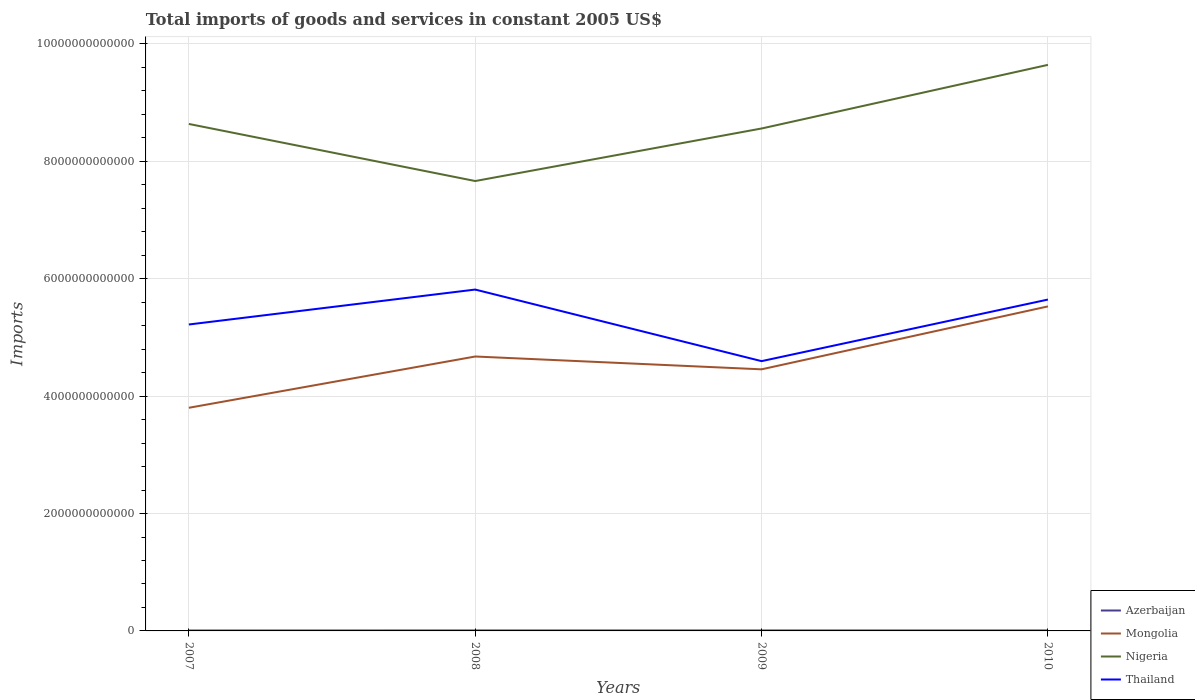How many different coloured lines are there?
Offer a very short reply. 4. Does the line corresponding to Thailand intersect with the line corresponding to Mongolia?
Your response must be concise. No. Is the number of lines equal to the number of legend labels?
Your response must be concise. Yes. Across all years, what is the maximum total imports of goods and services in Thailand?
Offer a terse response. 4.60e+12. In which year was the total imports of goods and services in Nigeria maximum?
Provide a succinct answer. 2008. What is the total total imports of goods and services in Nigeria in the graph?
Give a very brief answer. -1.08e+12. What is the difference between the highest and the second highest total imports of goods and services in Thailand?
Provide a succinct answer. 1.22e+12. What is the difference between the highest and the lowest total imports of goods and services in Thailand?
Your answer should be compact. 2. How many lines are there?
Offer a terse response. 4. How many years are there in the graph?
Give a very brief answer. 4. What is the difference between two consecutive major ticks on the Y-axis?
Provide a succinct answer. 2.00e+12. Are the values on the major ticks of Y-axis written in scientific E-notation?
Make the answer very short. No. Does the graph contain any zero values?
Keep it short and to the point. No. Does the graph contain grids?
Your answer should be very brief. Yes. Where does the legend appear in the graph?
Offer a very short reply. Bottom right. What is the title of the graph?
Your response must be concise. Total imports of goods and services in constant 2005 US$. What is the label or title of the X-axis?
Offer a terse response. Years. What is the label or title of the Y-axis?
Give a very brief answer. Imports. What is the Imports of Azerbaijan in 2007?
Offer a very short reply. 7.29e+09. What is the Imports in Mongolia in 2007?
Provide a short and direct response. 3.80e+12. What is the Imports of Nigeria in 2007?
Offer a very short reply. 8.64e+12. What is the Imports in Thailand in 2007?
Your answer should be very brief. 5.22e+12. What is the Imports of Azerbaijan in 2008?
Make the answer very short. 8.33e+09. What is the Imports in Mongolia in 2008?
Provide a short and direct response. 4.68e+12. What is the Imports of Nigeria in 2008?
Your answer should be very brief. 7.67e+12. What is the Imports of Thailand in 2008?
Ensure brevity in your answer.  5.82e+12. What is the Imports in Azerbaijan in 2009?
Your answer should be compact. 7.89e+09. What is the Imports of Mongolia in 2009?
Make the answer very short. 4.46e+12. What is the Imports in Nigeria in 2009?
Make the answer very short. 8.56e+12. What is the Imports of Thailand in 2009?
Provide a short and direct response. 4.60e+12. What is the Imports in Azerbaijan in 2010?
Keep it short and to the point. 8.00e+09. What is the Imports in Mongolia in 2010?
Your answer should be very brief. 5.53e+12. What is the Imports in Nigeria in 2010?
Ensure brevity in your answer.  9.64e+12. What is the Imports in Thailand in 2010?
Make the answer very short. 5.65e+12. Across all years, what is the maximum Imports in Azerbaijan?
Provide a short and direct response. 8.33e+09. Across all years, what is the maximum Imports in Mongolia?
Offer a very short reply. 5.53e+12. Across all years, what is the maximum Imports of Nigeria?
Your response must be concise. 9.64e+12. Across all years, what is the maximum Imports in Thailand?
Your response must be concise. 5.82e+12. Across all years, what is the minimum Imports in Azerbaijan?
Provide a succinct answer. 7.29e+09. Across all years, what is the minimum Imports in Mongolia?
Offer a terse response. 3.80e+12. Across all years, what is the minimum Imports of Nigeria?
Give a very brief answer. 7.67e+12. Across all years, what is the minimum Imports in Thailand?
Ensure brevity in your answer.  4.60e+12. What is the total Imports in Azerbaijan in the graph?
Offer a terse response. 3.15e+1. What is the total Imports of Mongolia in the graph?
Give a very brief answer. 1.85e+13. What is the total Imports of Nigeria in the graph?
Offer a very short reply. 3.45e+13. What is the total Imports of Thailand in the graph?
Offer a terse response. 2.13e+13. What is the difference between the Imports of Azerbaijan in 2007 and that in 2008?
Offer a terse response. -1.04e+09. What is the difference between the Imports of Mongolia in 2007 and that in 2008?
Offer a very short reply. -8.74e+11. What is the difference between the Imports in Nigeria in 2007 and that in 2008?
Provide a short and direct response. 9.72e+11. What is the difference between the Imports in Thailand in 2007 and that in 2008?
Ensure brevity in your answer.  -5.95e+11. What is the difference between the Imports in Azerbaijan in 2007 and that in 2009?
Offer a terse response. -6.05e+08. What is the difference between the Imports of Mongolia in 2007 and that in 2009?
Give a very brief answer. -6.55e+11. What is the difference between the Imports in Nigeria in 2007 and that in 2009?
Keep it short and to the point. 7.73e+1. What is the difference between the Imports in Thailand in 2007 and that in 2009?
Offer a very short reply. 6.24e+11. What is the difference between the Imports of Azerbaijan in 2007 and that in 2010?
Keep it short and to the point. -7.11e+08. What is the difference between the Imports in Mongolia in 2007 and that in 2010?
Your answer should be very brief. -1.73e+12. What is the difference between the Imports in Nigeria in 2007 and that in 2010?
Your answer should be very brief. -1.01e+12. What is the difference between the Imports in Thailand in 2007 and that in 2010?
Keep it short and to the point. -4.25e+11. What is the difference between the Imports in Azerbaijan in 2008 and that in 2009?
Ensure brevity in your answer.  4.40e+08. What is the difference between the Imports in Mongolia in 2008 and that in 2009?
Offer a terse response. 2.19e+11. What is the difference between the Imports in Nigeria in 2008 and that in 2009?
Make the answer very short. -8.95e+11. What is the difference between the Imports of Thailand in 2008 and that in 2009?
Offer a very short reply. 1.22e+12. What is the difference between the Imports in Azerbaijan in 2008 and that in 2010?
Your answer should be very brief. 3.33e+08. What is the difference between the Imports of Mongolia in 2008 and that in 2010?
Offer a very short reply. -8.53e+11. What is the difference between the Imports in Nigeria in 2008 and that in 2010?
Make the answer very short. -1.98e+12. What is the difference between the Imports in Thailand in 2008 and that in 2010?
Offer a terse response. 1.70e+11. What is the difference between the Imports in Azerbaijan in 2009 and that in 2010?
Offer a very short reply. -1.06e+08. What is the difference between the Imports of Mongolia in 2009 and that in 2010?
Keep it short and to the point. -1.07e+12. What is the difference between the Imports of Nigeria in 2009 and that in 2010?
Your answer should be very brief. -1.08e+12. What is the difference between the Imports in Thailand in 2009 and that in 2010?
Provide a succinct answer. -1.05e+12. What is the difference between the Imports in Azerbaijan in 2007 and the Imports in Mongolia in 2008?
Ensure brevity in your answer.  -4.67e+12. What is the difference between the Imports of Azerbaijan in 2007 and the Imports of Nigeria in 2008?
Your answer should be compact. -7.66e+12. What is the difference between the Imports in Azerbaijan in 2007 and the Imports in Thailand in 2008?
Give a very brief answer. -5.81e+12. What is the difference between the Imports in Mongolia in 2007 and the Imports in Nigeria in 2008?
Provide a succinct answer. -3.86e+12. What is the difference between the Imports in Mongolia in 2007 and the Imports in Thailand in 2008?
Provide a short and direct response. -2.01e+12. What is the difference between the Imports of Nigeria in 2007 and the Imports of Thailand in 2008?
Provide a short and direct response. 2.82e+12. What is the difference between the Imports of Azerbaijan in 2007 and the Imports of Mongolia in 2009?
Offer a very short reply. -4.45e+12. What is the difference between the Imports of Azerbaijan in 2007 and the Imports of Nigeria in 2009?
Offer a terse response. -8.55e+12. What is the difference between the Imports in Azerbaijan in 2007 and the Imports in Thailand in 2009?
Ensure brevity in your answer.  -4.59e+12. What is the difference between the Imports of Mongolia in 2007 and the Imports of Nigeria in 2009?
Offer a very short reply. -4.76e+12. What is the difference between the Imports in Mongolia in 2007 and the Imports in Thailand in 2009?
Keep it short and to the point. -7.95e+11. What is the difference between the Imports of Nigeria in 2007 and the Imports of Thailand in 2009?
Provide a succinct answer. 4.04e+12. What is the difference between the Imports of Azerbaijan in 2007 and the Imports of Mongolia in 2010?
Provide a succinct answer. -5.52e+12. What is the difference between the Imports of Azerbaijan in 2007 and the Imports of Nigeria in 2010?
Give a very brief answer. -9.64e+12. What is the difference between the Imports of Azerbaijan in 2007 and the Imports of Thailand in 2010?
Offer a terse response. -5.64e+12. What is the difference between the Imports of Mongolia in 2007 and the Imports of Nigeria in 2010?
Keep it short and to the point. -5.84e+12. What is the difference between the Imports of Mongolia in 2007 and the Imports of Thailand in 2010?
Your answer should be very brief. -1.84e+12. What is the difference between the Imports in Nigeria in 2007 and the Imports in Thailand in 2010?
Provide a succinct answer. 2.99e+12. What is the difference between the Imports in Azerbaijan in 2008 and the Imports in Mongolia in 2009?
Your answer should be compact. -4.45e+12. What is the difference between the Imports in Azerbaijan in 2008 and the Imports in Nigeria in 2009?
Your answer should be very brief. -8.55e+12. What is the difference between the Imports of Azerbaijan in 2008 and the Imports of Thailand in 2009?
Make the answer very short. -4.59e+12. What is the difference between the Imports of Mongolia in 2008 and the Imports of Nigeria in 2009?
Offer a terse response. -3.88e+12. What is the difference between the Imports of Mongolia in 2008 and the Imports of Thailand in 2009?
Provide a short and direct response. 7.91e+1. What is the difference between the Imports of Nigeria in 2008 and the Imports of Thailand in 2009?
Your answer should be very brief. 3.07e+12. What is the difference between the Imports in Azerbaijan in 2008 and the Imports in Mongolia in 2010?
Offer a very short reply. -5.52e+12. What is the difference between the Imports of Azerbaijan in 2008 and the Imports of Nigeria in 2010?
Your response must be concise. -9.64e+12. What is the difference between the Imports of Azerbaijan in 2008 and the Imports of Thailand in 2010?
Offer a very short reply. -5.64e+12. What is the difference between the Imports in Mongolia in 2008 and the Imports in Nigeria in 2010?
Give a very brief answer. -4.97e+12. What is the difference between the Imports in Mongolia in 2008 and the Imports in Thailand in 2010?
Ensure brevity in your answer.  -9.70e+11. What is the difference between the Imports in Nigeria in 2008 and the Imports in Thailand in 2010?
Keep it short and to the point. 2.02e+12. What is the difference between the Imports in Azerbaijan in 2009 and the Imports in Mongolia in 2010?
Provide a succinct answer. -5.52e+12. What is the difference between the Imports of Azerbaijan in 2009 and the Imports of Nigeria in 2010?
Ensure brevity in your answer.  -9.64e+12. What is the difference between the Imports of Azerbaijan in 2009 and the Imports of Thailand in 2010?
Your response must be concise. -5.64e+12. What is the difference between the Imports of Mongolia in 2009 and the Imports of Nigeria in 2010?
Provide a succinct answer. -5.19e+12. What is the difference between the Imports in Mongolia in 2009 and the Imports in Thailand in 2010?
Offer a very short reply. -1.19e+12. What is the difference between the Imports of Nigeria in 2009 and the Imports of Thailand in 2010?
Give a very brief answer. 2.91e+12. What is the average Imports of Azerbaijan per year?
Make the answer very short. 7.88e+09. What is the average Imports of Mongolia per year?
Your answer should be compact. 4.62e+12. What is the average Imports of Nigeria per year?
Keep it short and to the point. 8.63e+12. What is the average Imports of Thailand per year?
Give a very brief answer. 5.32e+12. In the year 2007, what is the difference between the Imports in Azerbaijan and Imports in Mongolia?
Ensure brevity in your answer.  -3.79e+12. In the year 2007, what is the difference between the Imports in Azerbaijan and Imports in Nigeria?
Your response must be concise. -8.63e+12. In the year 2007, what is the difference between the Imports of Azerbaijan and Imports of Thailand?
Your response must be concise. -5.21e+12. In the year 2007, what is the difference between the Imports of Mongolia and Imports of Nigeria?
Your answer should be compact. -4.84e+12. In the year 2007, what is the difference between the Imports in Mongolia and Imports in Thailand?
Provide a succinct answer. -1.42e+12. In the year 2007, what is the difference between the Imports of Nigeria and Imports of Thailand?
Offer a very short reply. 3.42e+12. In the year 2008, what is the difference between the Imports of Azerbaijan and Imports of Mongolia?
Provide a short and direct response. -4.67e+12. In the year 2008, what is the difference between the Imports of Azerbaijan and Imports of Nigeria?
Ensure brevity in your answer.  -7.66e+12. In the year 2008, what is the difference between the Imports in Azerbaijan and Imports in Thailand?
Your answer should be very brief. -5.81e+12. In the year 2008, what is the difference between the Imports of Mongolia and Imports of Nigeria?
Make the answer very short. -2.99e+12. In the year 2008, what is the difference between the Imports in Mongolia and Imports in Thailand?
Make the answer very short. -1.14e+12. In the year 2008, what is the difference between the Imports in Nigeria and Imports in Thailand?
Provide a succinct answer. 1.85e+12. In the year 2009, what is the difference between the Imports of Azerbaijan and Imports of Mongolia?
Make the answer very short. -4.45e+12. In the year 2009, what is the difference between the Imports in Azerbaijan and Imports in Nigeria?
Provide a short and direct response. -8.55e+12. In the year 2009, what is the difference between the Imports of Azerbaijan and Imports of Thailand?
Your answer should be compact. -4.59e+12. In the year 2009, what is the difference between the Imports in Mongolia and Imports in Nigeria?
Provide a short and direct response. -4.10e+12. In the year 2009, what is the difference between the Imports in Mongolia and Imports in Thailand?
Offer a very short reply. -1.39e+11. In the year 2009, what is the difference between the Imports in Nigeria and Imports in Thailand?
Provide a short and direct response. 3.96e+12. In the year 2010, what is the difference between the Imports in Azerbaijan and Imports in Mongolia?
Your response must be concise. -5.52e+12. In the year 2010, what is the difference between the Imports in Azerbaijan and Imports in Nigeria?
Provide a short and direct response. -9.64e+12. In the year 2010, what is the difference between the Imports in Azerbaijan and Imports in Thailand?
Make the answer very short. -5.64e+12. In the year 2010, what is the difference between the Imports in Mongolia and Imports in Nigeria?
Provide a succinct answer. -4.12e+12. In the year 2010, what is the difference between the Imports of Mongolia and Imports of Thailand?
Give a very brief answer. -1.17e+11. In the year 2010, what is the difference between the Imports in Nigeria and Imports in Thailand?
Your response must be concise. 4.00e+12. What is the ratio of the Imports of Azerbaijan in 2007 to that in 2008?
Ensure brevity in your answer.  0.87. What is the ratio of the Imports of Mongolia in 2007 to that in 2008?
Give a very brief answer. 0.81. What is the ratio of the Imports in Nigeria in 2007 to that in 2008?
Your response must be concise. 1.13. What is the ratio of the Imports in Thailand in 2007 to that in 2008?
Your answer should be very brief. 0.9. What is the ratio of the Imports in Azerbaijan in 2007 to that in 2009?
Your answer should be compact. 0.92. What is the ratio of the Imports in Mongolia in 2007 to that in 2009?
Your answer should be compact. 0.85. What is the ratio of the Imports in Nigeria in 2007 to that in 2009?
Provide a succinct answer. 1.01. What is the ratio of the Imports of Thailand in 2007 to that in 2009?
Your answer should be compact. 1.14. What is the ratio of the Imports of Azerbaijan in 2007 to that in 2010?
Offer a terse response. 0.91. What is the ratio of the Imports of Mongolia in 2007 to that in 2010?
Ensure brevity in your answer.  0.69. What is the ratio of the Imports of Nigeria in 2007 to that in 2010?
Your response must be concise. 0.9. What is the ratio of the Imports of Thailand in 2007 to that in 2010?
Your answer should be compact. 0.92. What is the ratio of the Imports in Azerbaijan in 2008 to that in 2009?
Offer a terse response. 1.06. What is the ratio of the Imports in Mongolia in 2008 to that in 2009?
Your answer should be compact. 1.05. What is the ratio of the Imports in Nigeria in 2008 to that in 2009?
Your response must be concise. 0.9. What is the ratio of the Imports of Thailand in 2008 to that in 2009?
Your response must be concise. 1.27. What is the ratio of the Imports in Azerbaijan in 2008 to that in 2010?
Give a very brief answer. 1.04. What is the ratio of the Imports of Mongolia in 2008 to that in 2010?
Your answer should be very brief. 0.85. What is the ratio of the Imports in Nigeria in 2008 to that in 2010?
Give a very brief answer. 0.79. What is the ratio of the Imports of Thailand in 2008 to that in 2010?
Keep it short and to the point. 1.03. What is the ratio of the Imports in Azerbaijan in 2009 to that in 2010?
Offer a very short reply. 0.99. What is the ratio of the Imports in Mongolia in 2009 to that in 2010?
Make the answer very short. 0.81. What is the ratio of the Imports of Nigeria in 2009 to that in 2010?
Your response must be concise. 0.89. What is the ratio of the Imports of Thailand in 2009 to that in 2010?
Make the answer very short. 0.81. What is the difference between the highest and the second highest Imports of Azerbaijan?
Your response must be concise. 3.33e+08. What is the difference between the highest and the second highest Imports in Mongolia?
Keep it short and to the point. 8.53e+11. What is the difference between the highest and the second highest Imports of Nigeria?
Your answer should be very brief. 1.01e+12. What is the difference between the highest and the second highest Imports of Thailand?
Offer a very short reply. 1.70e+11. What is the difference between the highest and the lowest Imports of Azerbaijan?
Provide a succinct answer. 1.04e+09. What is the difference between the highest and the lowest Imports of Mongolia?
Give a very brief answer. 1.73e+12. What is the difference between the highest and the lowest Imports of Nigeria?
Your answer should be very brief. 1.98e+12. What is the difference between the highest and the lowest Imports of Thailand?
Keep it short and to the point. 1.22e+12. 